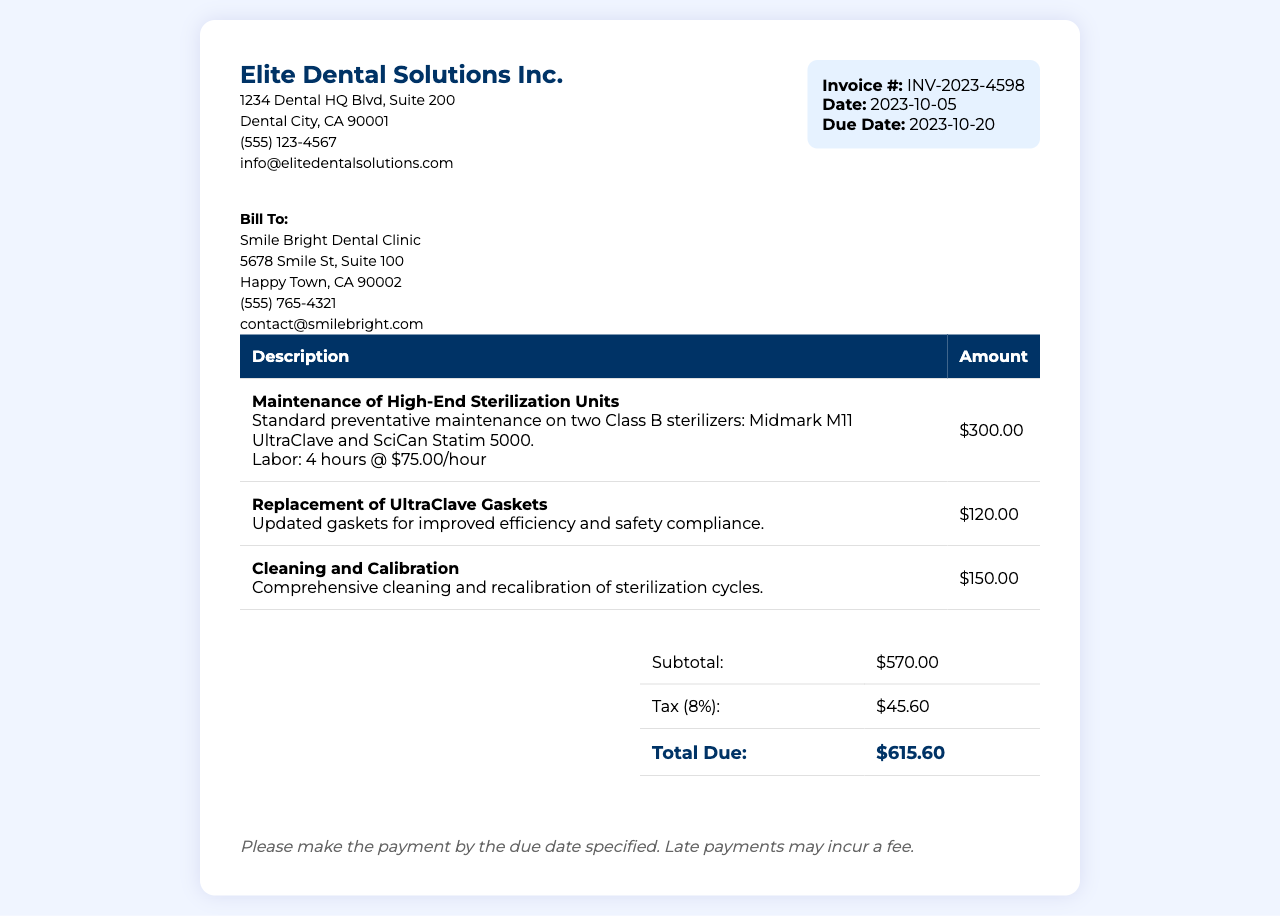What is the invoice number? The invoice number is listed in the document as the unique identifier for the transaction.
Answer: INV-2023-4598 What is the total due amount? The total due amount is the final sum calculated after adding subtotal and tax.
Answer: $615.60 Who is the billing client? The document specifies the name of the client who is being billed for the services.
Answer: Smile Bright Dental Clinic What is the tax rate applied? The tax rate is noted in the summary section of the invoice as a percentage.
Answer: 8% How many hours of labor were performed? The document indicates the total hours that labor was charged for in the maintenance service description.
Answer: 4 hours What is included in the maintenance service? The description provides details on what was performed during the maintenance service for clarity.
Answer: Maintenance of High-End Sterilization Units What is the due date for this invoice? The due date is specified clearly in the invoice details for payment.
Answer: 2023-10-20 What is the subtotal amount before tax? The subtotal is the sum of all services rendered prior to applying any tax.
Answer: $570.00 Who is the service provider? The company providing the services is mentioned at the top of the invoice.
Answer: Elite Dental Solutions Inc 